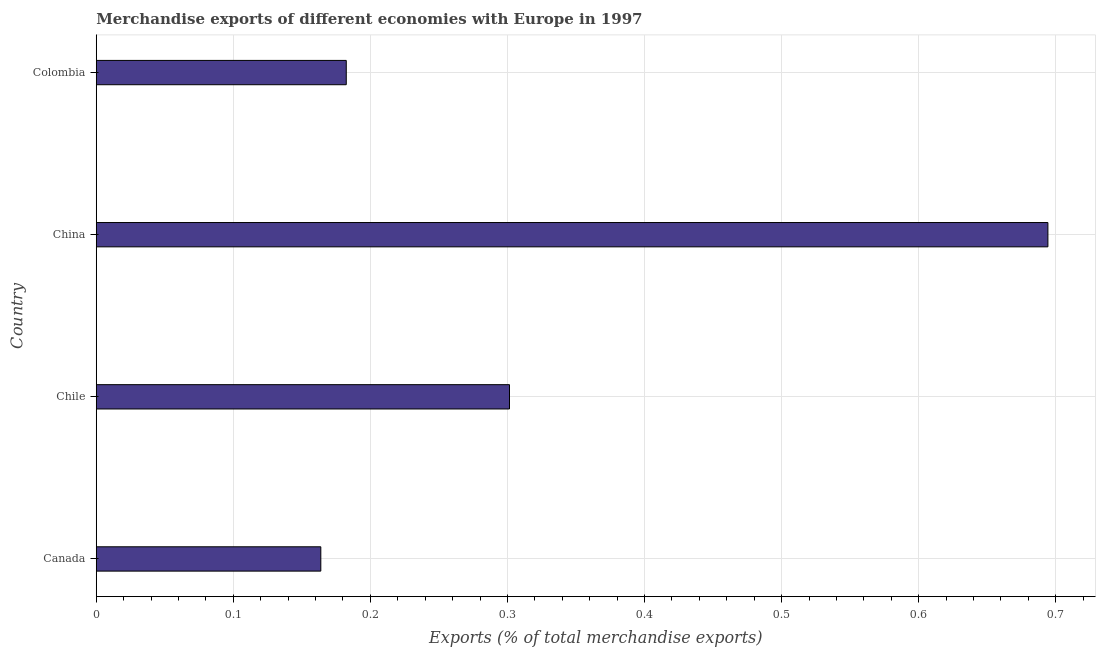What is the title of the graph?
Provide a short and direct response. Merchandise exports of different economies with Europe in 1997. What is the label or title of the X-axis?
Offer a very short reply. Exports (% of total merchandise exports). What is the label or title of the Y-axis?
Offer a terse response. Country. What is the merchandise exports in Chile?
Offer a very short reply. 0.3. Across all countries, what is the maximum merchandise exports?
Your response must be concise. 0.69. Across all countries, what is the minimum merchandise exports?
Offer a terse response. 0.16. In which country was the merchandise exports maximum?
Offer a terse response. China. In which country was the merchandise exports minimum?
Your answer should be very brief. Canada. What is the sum of the merchandise exports?
Offer a very short reply. 1.34. What is the difference between the merchandise exports in Canada and Chile?
Keep it short and to the point. -0.14. What is the average merchandise exports per country?
Provide a succinct answer. 0.34. What is the median merchandise exports?
Make the answer very short. 0.24. In how many countries, is the merchandise exports greater than 0.3 %?
Offer a terse response. 2. What is the ratio of the merchandise exports in Chile to that in Colombia?
Your answer should be compact. 1.65. Is the merchandise exports in Chile less than that in Colombia?
Give a very brief answer. No. Is the difference between the merchandise exports in Canada and Colombia greater than the difference between any two countries?
Your answer should be compact. No. What is the difference between the highest and the second highest merchandise exports?
Ensure brevity in your answer.  0.39. Is the sum of the merchandise exports in Canada and Chile greater than the maximum merchandise exports across all countries?
Offer a very short reply. No. What is the difference between the highest and the lowest merchandise exports?
Offer a terse response. 0.53. In how many countries, is the merchandise exports greater than the average merchandise exports taken over all countries?
Provide a short and direct response. 1. Are all the bars in the graph horizontal?
Provide a short and direct response. Yes. How many countries are there in the graph?
Offer a terse response. 4. Are the values on the major ticks of X-axis written in scientific E-notation?
Provide a short and direct response. No. What is the Exports (% of total merchandise exports) of Canada?
Offer a terse response. 0.16. What is the Exports (% of total merchandise exports) in Chile?
Provide a short and direct response. 0.3. What is the Exports (% of total merchandise exports) in China?
Keep it short and to the point. 0.69. What is the Exports (% of total merchandise exports) in Colombia?
Your answer should be very brief. 0.18. What is the difference between the Exports (% of total merchandise exports) in Canada and Chile?
Offer a terse response. -0.14. What is the difference between the Exports (% of total merchandise exports) in Canada and China?
Your answer should be very brief. -0.53. What is the difference between the Exports (% of total merchandise exports) in Canada and Colombia?
Your answer should be very brief. -0.02. What is the difference between the Exports (% of total merchandise exports) in Chile and China?
Your response must be concise. -0.39. What is the difference between the Exports (% of total merchandise exports) in Chile and Colombia?
Provide a short and direct response. 0.12. What is the difference between the Exports (% of total merchandise exports) in China and Colombia?
Provide a succinct answer. 0.51. What is the ratio of the Exports (% of total merchandise exports) in Canada to that in Chile?
Your response must be concise. 0.54. What is the ratio of the Exports (% of total merchandise exports) in Canada to that in China?
Offer a terse response. 0.24. What is the ratio of the Exports (% of total merchandise exports) in Canada to that in Colombia?
Provide a short and direct response. 0.9. What is the ratio of the Exports (% of total merchandise exports) in Chile to that in China?
Offer a very short reply. 0.43. What is the ratio of the Exports (% of total merchandise exports) in Chile to that in Colombia?
Your answer should be compact. 1.65. What is the ratio of the Exports (% of total merchandise exports) in China to that in Colombia?
Provide a short and direct response. 3.81. 